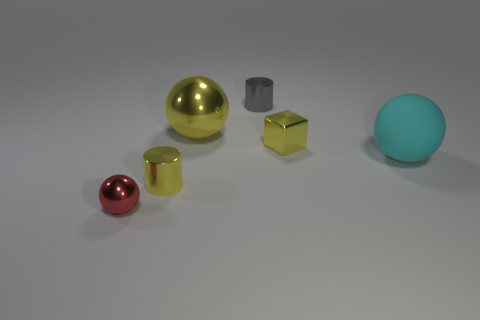What size is the yellow cylinder that is the same material as the gray cylinder?
Offer a very short reply. Small. What number of things are either metallic spheres in front of the rubber object or yellow shiny cylinders?
Offer a terse response. 2. There is a metal cylinder in front of the cyan ball; is its color the same as the block?
Ensure brevity in your answer.  Yes. There is a yellow metallic thing that is the same shape as the tiny gray shiny thing; what is its size?
Your answer should be very brief. Small. The metallic cylinder in front of the yellow metallic thing on the right side of the cylinder behind the large cyan matte ball is what color?
Provide a succinct answer. Yellow. Is the material of the large cyan object the same as the yellow block?
Your answer should be compact. No. Is there a big yellow metallic thing on the left side of the metal ball on the left side of the shiny ball that is right of the small red metal ball?
Your answer should be compact. No. Is the small block the same color as the rubber thing?
Your response must be concise. No. Is the number of tiny yellow shiny cylinders less than the number of tiny blue rubber spheres?
Give a very brief answer. No. Is the large sphere that is to the left of the gray object made of the same material as the cylinder that is right of the big yellow metal ball?
Keep it short and to the point. Yes. 